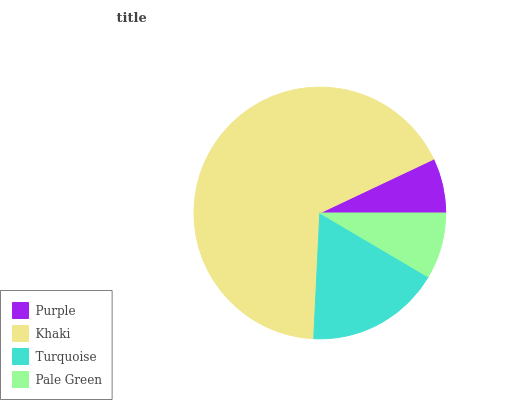Is Purple the minimum?
Answer yes or no. Yes. Is Khaki the maximum?
Answer yes or no. Yes. Is Turquoise the minimum?
Answer yes or no. No. Is Turquoise the maximum?
Answer yes or no. No. Is Khaki greater than Turquoise?
Answer yes or no. Yes. Is Turquoise less than Khaki?
Answer yes or no. Yes. Is Turquoise greater than Khaki?
Answer yes or no. No. Is Khaki less than Turquoise?
Answer yes or no. No. Is Turquoise the high median?
Answer yes or no. Yes. Is Pale Green the low median?
Answer yes or no. Yes. Is Khaki the high median?
Answer yes or no. No. Is Purple the low median?
Answer yes or no. No. 